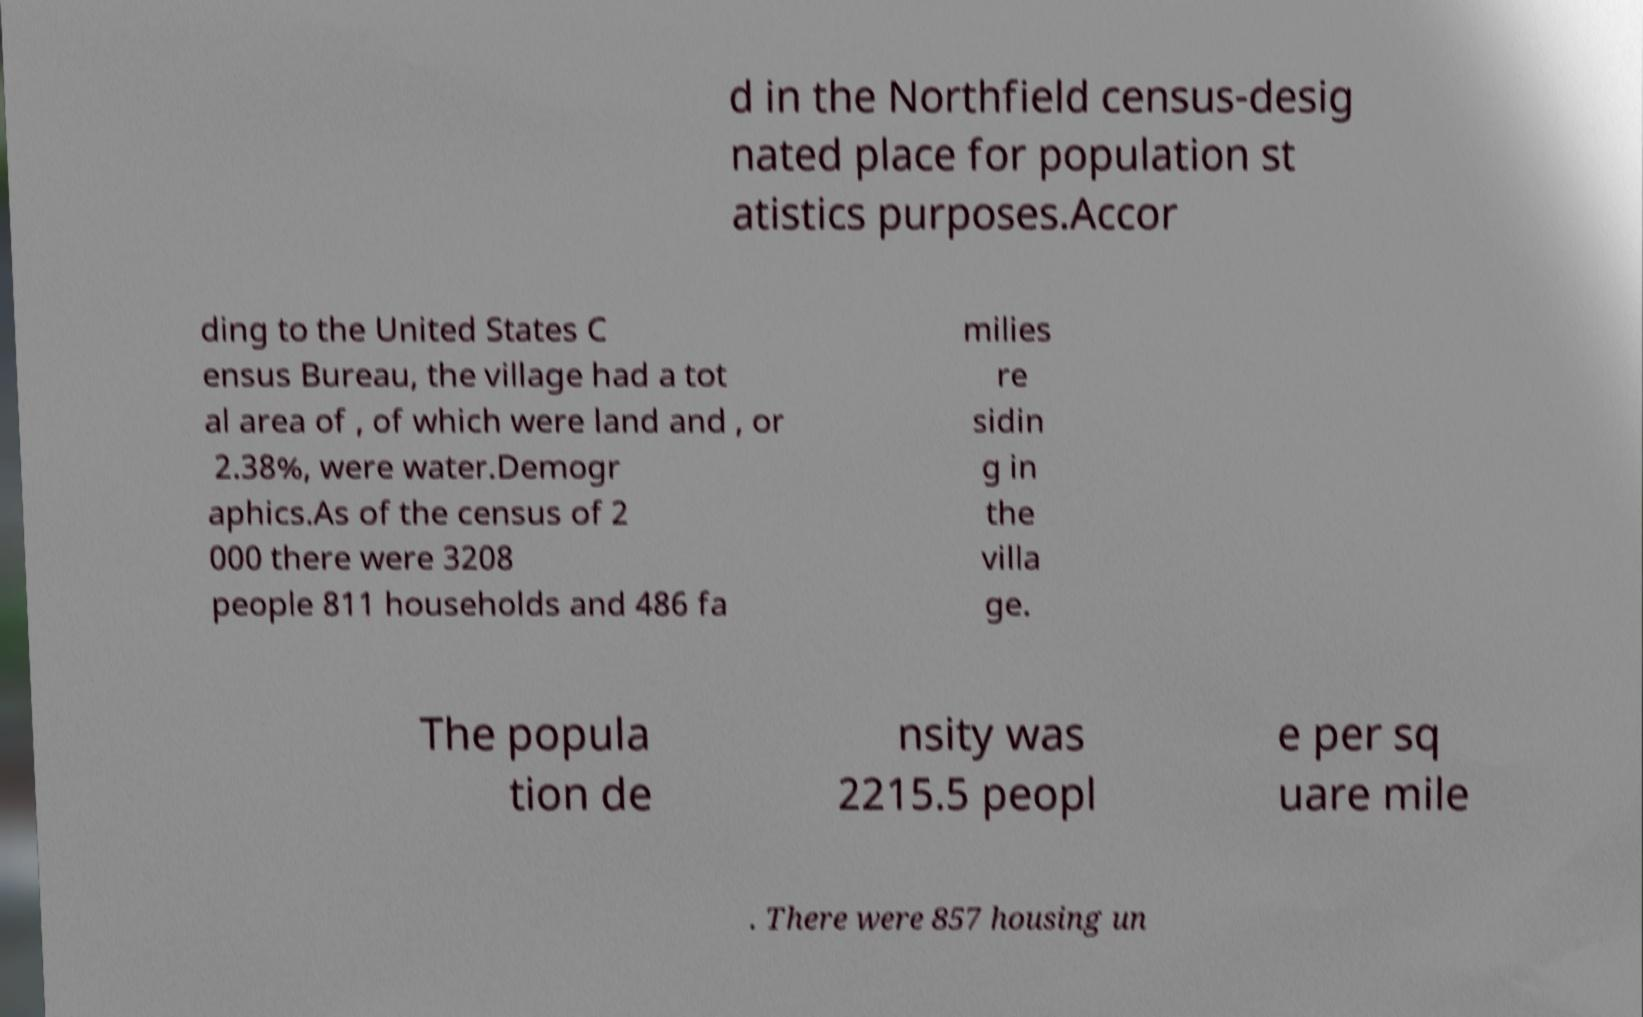I need the written content from this picture converted into text. Can you do that? d in the Northfield census-desig nated place for population st atistics purposes.Accor ding to the United States C ensus Bureau, the village had a tot al area of , of which were land and , or 2.38%, were water.Demogr aphics.As of the census of 2 000 there were 3208 people 811 households and 486 fa milies re sidin g in the villa ge. The popula tion de nsity was 2215.5 peopl e per sq uare mile . There were 857 housing un 